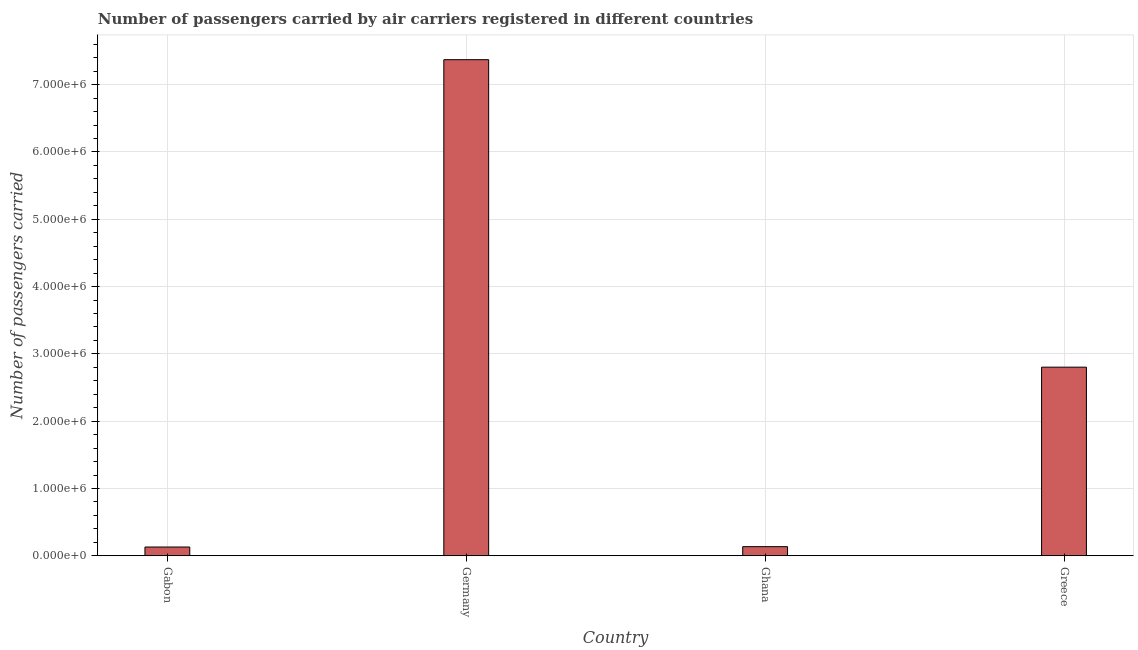Does the graph contain any zero values?
Your response must be concise. No. Does the graph contain grids?
Your answer should be compact. Yes. What is the title of the graph?
Your answer should be very brief. Number of passengers carried by air carriers registered in different countries. What is the label or title of the Y-axis?
Give a very brief answer. Number of passengers carried. What is the number of passengers carried in Gabon?
Make the answer very short. 1.30e+05. Across all countries, what is the maximum number of passengers carried?
Your answer should be compact. 7.37e+06. Across all countries, what is the minimum number of passengers carried?
Offer a terse response. 1.30e+05. In which country was the number of passengers carried minimum?
Keep it short and to the point. Gabon. What is the sum of the number of passengers carried?
Provide a succinct answer. 1.04e+07. What is the difference between the number of passengers carried in Gabon and Germany?
Provide a short and direct response. -7.24e+06. What is the average number of passengers carried per country?
Your response must be concise. 2.61e+06. What is the median number of passengers carried?
Provide a short and direct response. 1.47e+06. In how many countries, is the number of passengers carried greater than 2200000 ?
Make the answer very short. 2. What is the ratio of the number of passengers carried in Gabon to that in Greece?
Your answer should be compact. 0.05. Is the number of passengers carried in Gabon less than that in Ghana?
Keep it short and to the point. Yes. What is the difference between the highest and the second highest number of passengers carried?
Your answer should be very brief. 4.57e+06. Is the sum of the number of passengers carried in Gabon and Germany greater than the maximum number of passengers carried across all countries?
Your answer should be compact. Yes. What is the difference between the highest and the lowest number of passengers carried?
Your response must be concise. 7.24e+06. How many bars are there?
Your answer should be compact. 4. Are all the bars in the graph horizontal?
Offer a terse response. No. What is the difference between two consecutive major ticks on the Y-axis?
Provide a succinct answer. 1.00e+06. What is the Number of passengers carried of Gabon?
Keep it short and to the point. 1.30e+05. What is the Number of passengers carried of Germany?
Offer a very short reply. 7.37e+06. What is the Number of passengers carried of Ghana?
Make the answer very short. 1.36e+05. What is the Number of passengers carried in Greece?
Give a very brief answer. 2.80e+06. What is the difference between the Number of passengers carried in Gabon and Germany?
Your answer should be very brief. -7.24e+06. What is the difference between the Number of passengers carried in Gabon and Ghana?
Your answer should be very brief. -5300. What is the difference between the Number of passengers carried in Gabon and Greece?
Your answer should be very brief. -2.67e+06. What is the difference between the Number of passengers carried in Germany and Ghana?
Provide a short and direct response. 7.24e+06. What is the difference between the Number of passengers carried in Germany and Greece?
Provide a short and direct response. 4.57e+06. What is the difference between the Number of passengers carried in Ghana and Greece?
Offer a terse response. -2.67e+06. What is the ratio of the Number of passengers carried in Gabon to that in Germany?
Give a very brief answer. 0.02. What is the ratio of the Number of passengers carried in Gabon to that in Ghana?
Ensure brevity in your answer.  0.96. What is the ratio of the Number of passengers carried in Gabon to that in Greece?
Your answer should be compact. 0.05. What is the ratio of the Number of passengers carried in Germany to that in Ghana?
Offer a terse response. 54.36. What is the ratio of the Number of passengers carried in Germany to that in Greece?
Keep it short and to the point. 2.63. What is the ratio of the Number of passengers carried in Ghana to that in Greece?
Offer a very short reply. 0.05. 